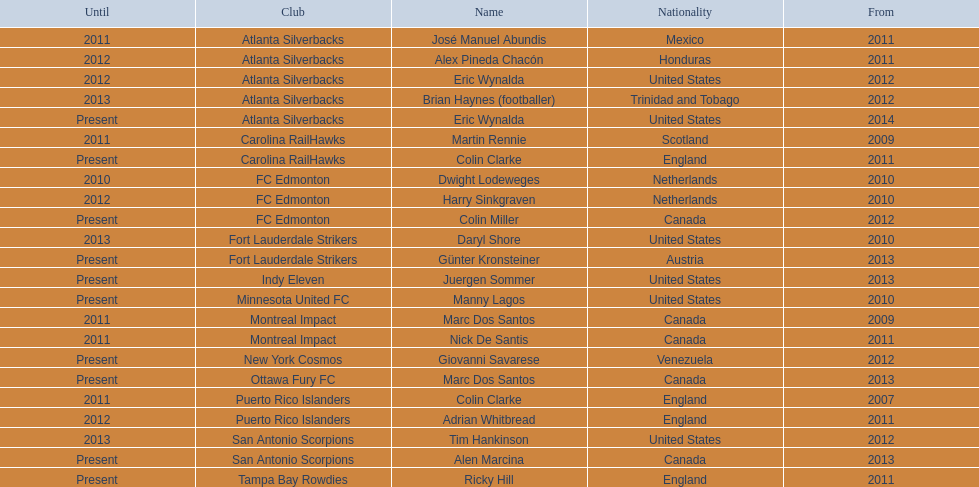What year did marc dos santos start as coach? 2009. Which other starting years correspond with this year? 2009. Who was the other coach with this starting year Martin Rennie. 